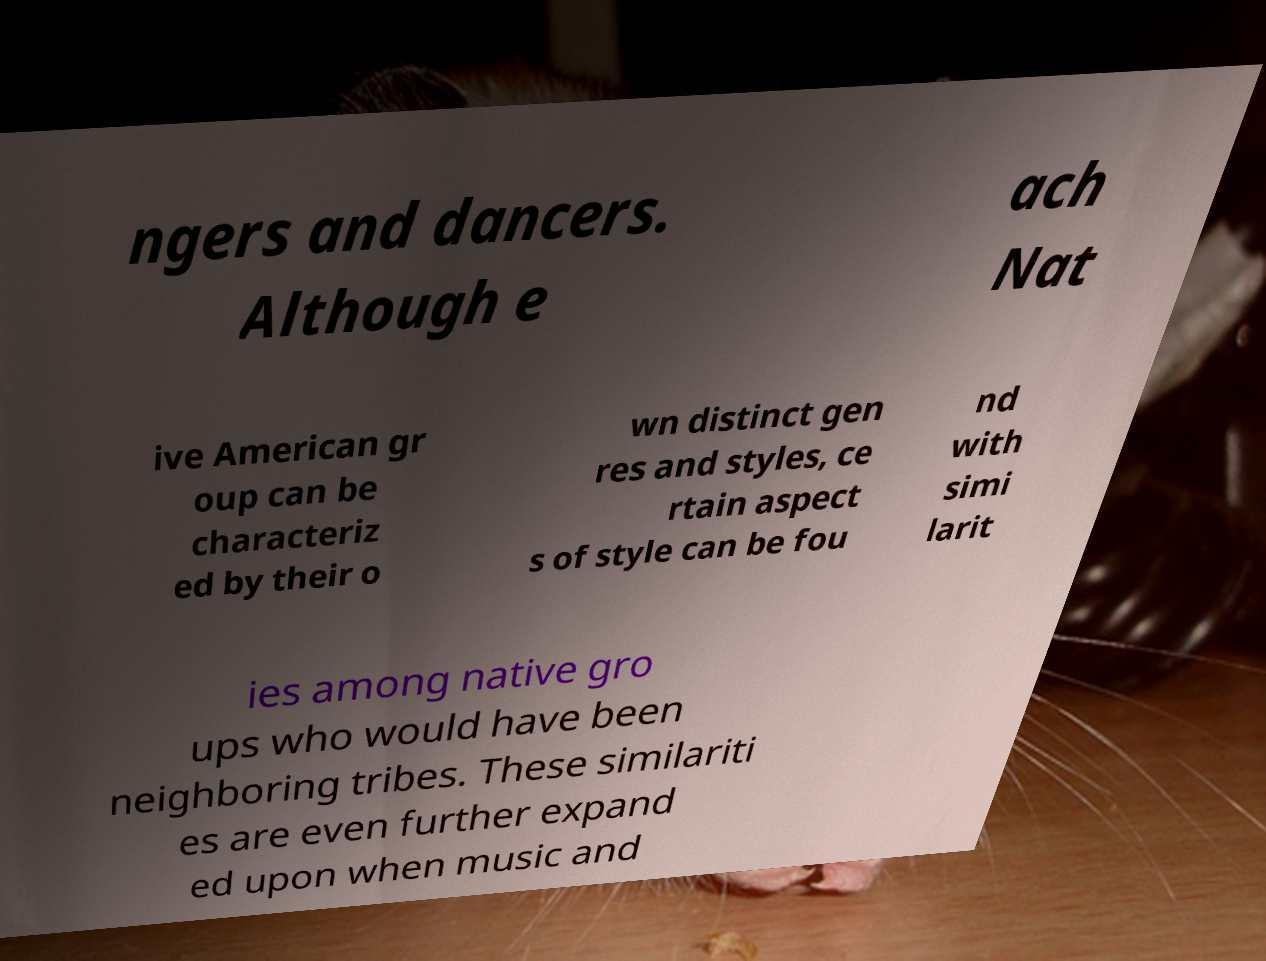Can you accurately transcribe the text from the provided image for me? ngers and dancers. Although e ach Nat ive American gr oup can be characteriz ed by their o wn distinct gen res and styles, ce rtain aspect s of style can be fou nd with simi larit ies among native gro ups who would have been neighboring tribes. These similariti es are even further expand ed upon when music and 